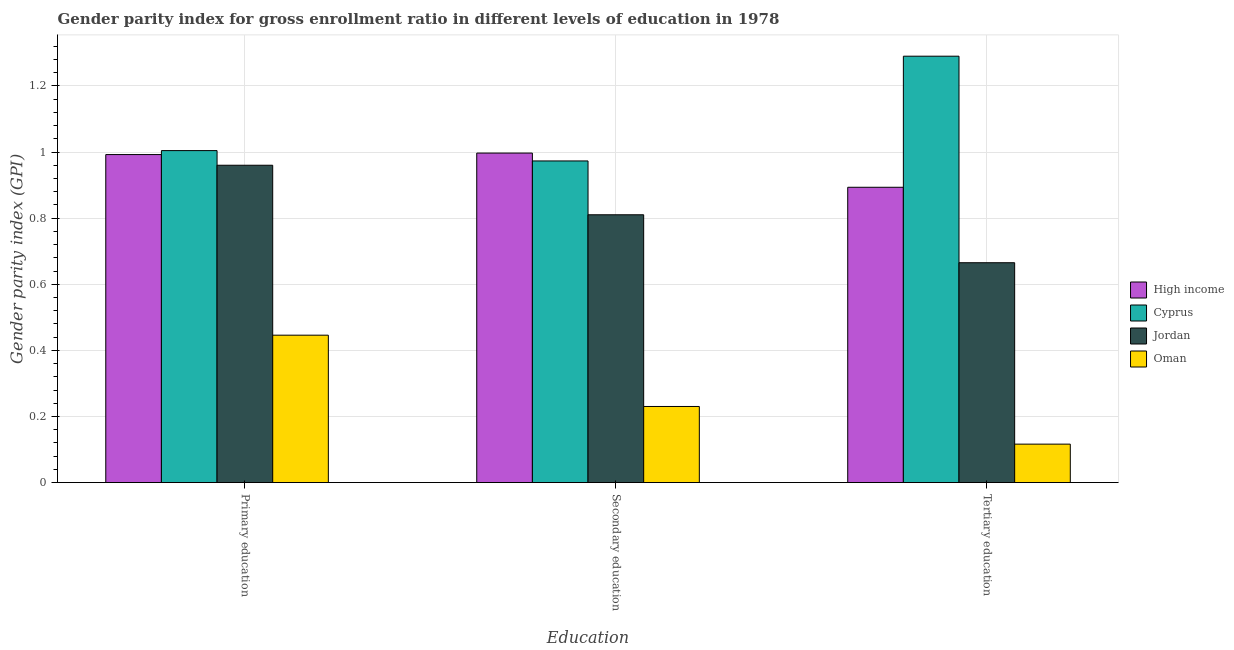How many groups of bars are there?
Provide a short and direct response. 3. How many bars are there on the 2nd tick from the left?
Provide a succinct answer. 4. What is the label of the 2nd group of bars from the left?
Ensure brevity in your answer.  Secondary education. What is the gender parity index in tertiary education in Jordan?
Offer a terse response. 0.67. Across all countries, what is the maximum gender parity index in primary education?
Offer a very short reply. 1. Across all countries, what is the minimum gender parity index in tertiary education?
Give a very brief answer. 0.12. In which country was the gender parity index in tertiary education maximum?
Offer a very short reply. Cyprus. In which country was the gender parity index in tertiary education minimum?
Offer a very short reply. Oman. What is the total gender parity index in tertiary education in the graph?
Make the answer very short. 2.97. What is the difference between the gender parity index in tertiary education in Oman and that in High income?
Provide a succinct answer. -0.78. What is the difference between the gender parity index in tertiary education in Oman and the gender parity index in primary education in Cyprus?
Give a very brief answer. -0.89. What is the average gender parity index in tertiary education per country?
Make the answer very short. 0.74. What is the difference between the gender parity index in secondary education and gender parity index in tertiary education in Jordan?
Offer a terse response. 0.15. In how many countries, is the gender parity index in tertiary education greater than 1 ?
Your answer should be compact. 1. What is the ratio of the gender parity index in tertiary education in Jordan to that in Oman?
Give a very brief answer. 5.71. What is the difference between the highest and the second highest gender parity index in primary education?
Provide a short and direct response. 0.01. What is the difference between the highest and the lowest gender parity index in secondary education?
Provide a short and direct response. 0.77. In how many countries, is the gender parity index in primary education greater than the average gender parity index in primary education taken over all countries?
Your response must be concise. 3. What does the 1st bar from the left in Tertiary education represents?
Your response must be concise. High income. What does the 4th bar from the right in Tertiary education represents?
Make the answer very short. High income. Are all the bars in the graph horizontal?
Keep it short and to the point. No. How many countries are there in the graph?
Provide a succinct answer. 4. Does the graph contain grids?
Ensure brevity in your answer.  Yes. How many legend labels are there?
Keep it short and to the point. 4. How are the legend labels stacked?
Keep it short and to the point. Vertical. What is the title of the graph?
Offer a terse response. Gender parity index for gross enrollment ratio in different levels of education in 1978. Does "Slovak Republic" appear as one of the legend labels in the graph?
Offer a very short reply. No. What is the label or title of the X-axis?
Provide a short and direct response. Education. What is the label or title of the Y-axis?
Your response must be concise. Gender parity index (GPI). What is the Gender parity index (GPI) of High income in Primary education?
Offer a very short reply. 0.99. What is the Gender parity index (GPI) in Cyprus in Primary education?
Make the answer very short. 1. What is the Gender parity index (GPI) of Jordan in Primary education?
Make the answer very short. 0.96. What is the Gender parity index (GPI) of Oman in Primary education?
Your response must be concise. 0.45. What is the Gender parity index (GPI) in High income in Secondary education?
Offer a terse response. 1. What is the Gender parity index (GPI) in Cyprus in Secondary education?
Provide a succinct answer. 0.97. What is the Gender parity index (GPI) of Jordan in Secondary education?
Your answer should be compact. 0.81. What is the Gender parity index (GPI) in Oman in Secondary education?
Make the answer very short. 0.23. What is the Gender parity index (GPI) of High income in Tertiary education?
Provide a short and direct response. 0.89. What is the Gender parity index (GPI) of Cyprus in Tertiary education?
Keep it short and to the point. 1.29. What is the Gender parity index (GPI) in Jordan in Tertiary education?
Offer a very short reply. 0.67. What is the Gender parity index (GPI) in Oman in Tertiary education?
Give a very brief answer. 0.12. Across all Education, what is the maximum Gender parity index (GPI) in High income?
Your answer should be very brief. 1. Across all Education, what is the maximum Gender parity index (GPI) in Cyprus?
Make the answer very short. 1.29. Across all Education, what is the maximum Gender parity index (GPI) of Jordan?
Keep it short and to the point. 0.96. Across all Education, what is the maximum Gender parity index (GPI) of Oman?
Make the answer very short. 0.45. Across all Education, what is the minimum Gender parity index (GPI) of High income?
Your answer should be compact. 0.89. Across all Education, what is the minimum Gender parity index (GPI) in Cyprus?
Your answer should be very brief. 0.97. Across all Education, what is the minimum Gender parity index (GPI) in Jordan?
Offer a very short reply. 0.67. Across all Education, what is the minimum Gender parity index (GPI) of Oman?
Offer a terse response. 0.12. What is the total Gender parity index (GPI) of High income in the graph?
Provide a short and direct response. 2.88. What is the total Gender parity index (GPI) in Cyprus in the graph?
Keep it short and to the point. 3.27. What is the total Gender parity index (GPI) of Jordan in the graph?
Your answer should be very brief. 2.44. What is the total Gender parity index (GPI) in Oman in the graph?
Provide a succinct answer. 0.79. What is the difference between the Gender parity index (GPI) of High income in Primary education and that in Secondary education?
Offer a terse response. -0. What is the difference between the Gender parity index (GPI) of Cyprus in Primary education and that in Secondary education?
Offer a terse response. 0.03. What is the difference between the Gender parity index (GPI) in Jordan in Primary education and that in Secondary education?
Give a very brief answer. 0.15. What is the difference between the Gender parity index (GPI) in Oman in Primary education and that in Secondary education?
Provide a succinct answer. 0.22. What is the difference between the Gender parity index (GPI) in High income in Primary education and that in Tertiary education?
Your response must be concise. 0.1. What is the difference between the Gender parity index (GPI) in Cyprus in Primary education and that in Tertiary education?
Ensure brevity in your answer.  -0.29. What is the difference between the Gender parity index (GPI) of Jordan in Primary education and that in Tertiary education?
Offer a terse response. 0.29. What is the difference between the Gender parity index (GPI) of Oman in Primary education and that in Tertiary education?
Provide a short and direct response. 0.33. What is the difference between the Gender parity index (GPI) of High income in Secondary education and that in Tertiary education?
Keep it short and to the point. 0.1. What is the difference between the Gender parity index (GPI) of Cyprus in Secondary education and that in Tertiary education?
Provide a succinct answer. -0.32. What is the difference between the Gender parity index (GPI) in Jordan in Secondary education and that in Tertiary education?
Your answer should be very brief. 0.15. What is the difference between the Gender parity index (GPI) of Oman in Secondary education and that in Tertiary education?
Keep it short and to the point. 0.11. What is the difference between the Gender parity index (GPI) of High income in Primary education and the Gender parity index (GPI) of Cyprus in Secondary education?
Offer a terse response. 0.02. What is the difference between the Gender parity index (GPI) in High income in Primary education and the Gender parity index (GPI) in Jordan in Secondary education?
Offer a very short reply. 0.18. What is the difference between the Gender parity index (GPI) in High income in Primary education and the Gender parity index (GPI) in Oman in Secondary education?
Ensure brevity in your answer.  0.76. What is the difference between the Gender parity index (GPI) in Cyprus in Primary education and the Gender parity index (GPI) in Jordan in Secondary education?
Provide a short and direct response. 0.19. What is the difference between the Gender parity index (GPI) of Cyprus in Primary education and the Gender parity index (GPI) of Oman in Secondary education?
Your answer should be very brief. 0.77. What is the difference between the Gender parity index (GPI) of Jordan in Primary education and the Gender parity index (GPI) of Oman in Secondary education?
Offer a very short reply. 0.73. What is the difference between the Gender parity index (GPI) of High income in Primary education and the Gender parity index (GPI) of Cyprus in Tertiary education?
Give a very brief answer. -0.3. What is the difference between the Gender parity index (GPI) in High income in Primary education and the Gender parity index (GPI) in Jordan in Tertiary education?
Your answer should be compact. 0.33. What is the difference between the Gender parity index (GPI) in High income in Primary education and the Gender parity index (GPI) in Oman in Tertiary education?
Offer a terse response. 0.88. What is the difference between the Gender parity index (GPI) of Cyprus in Primary education and the Gender parity index (GPI) of Jordan in Tertiary education?
Your answer should be very brief. 0.34. What is the difference between the Gender parity index (GPI) in Cyprus in Primary education and the Gender parity index (GPI) in Oman in Tertiary education?
Your answer should be very brief. 0.89. What is the difference between the Gender parity index (GPI) of Jordan in Primary education and the Gender parity index (GPI) of Oman in Tertiary education?
Make the answer very short. 0.84. What is the difference between the Gender parity index (GPI) in High income in Secondary education and the Gender parity index (GPI) in Cyprus in Tertiary education?
Keep it short and to the point. -0.29. What is the difference between the Gender parity index (GPI) of High income in Secondary education and the Gender parity index (GPI) of Jordan in Tertiary education?
Your response must be concise. 0.33. What is the difference between the Gender parity index (GPI) in High income in Secondary education and the Gender parity index (GPI) in Oman in Tertiary education?
Offer a very short reply. 0.88. What is the difference between the Gender parity index (GPI) of Cyprus in Secondary education and the Gender parity index (GPI) of Jordan in Tertiary education?
Offer a very short reply. 0.31. What is the difference between the Gender parity index (GPI) in Cyprus in Secondary education and the Gender parity index (GPI) in Oman in Tertiary education?
Provide a succinct answer. 0.86. What is the difference between the Gender parity index (GPI) of Jordan in Secondary education and the Gender parity index (GPI) of Oman in Tertiary education?
Provide a short and direct response. 0.69. What is the average Gender parity index (GPI) of High income per Education?
Provide a succinct answer. 0.96. What is the average Gender parity index (GPI) in Cyprus per Education?
Offer a terse response. 1.09. What is the average Gender parity index (GPI) in Jordan per Education?
Offer a very short reply. 0.81. What is the average Gender parity index (GPI) of Oman per Education?
Give a very brief answer. 0.26. What is the difference between the Gender parity index (GPI) in High income and Gender parity index (GPI) in Cyprus in Primary education?
Your response must be concise. -0.01. What is the difference between the Gender parity index (GPI) of High income and Gender parity index (GPI) of Jordan in Primary education?
Your answer should be compact. 0.03. What is the difference between the Gender parity index (GPI) in High income and Gender parity index (GPI) in Oman in Primary education?
Keep it short and to the point. 0.55. What is the difference between the Gender parity index (GPI) of Cyprus and Gender parity index (GPI) of Jordan in Primary education?
Your answer should be very brief. 0.04. What is the difference between the Gender parity index (GPI) in Cyprus and Gender parity index (GPI) in Oman in Primary education?
Your answer should be very brief. 0.56. What is the difference between the Gender parity index (GPI) in Jordan and Gender parity index (GPI) in Oman in Primary education?
Keep it short and to the point. 0.51. What is the difference between the Gender parity index (GPI) of High income and Gender parity index (GPI) of Cyprus in Secondary education?
Offer a terse response. 0.02. What is the difference between the Gender parity index (GPI) in High income and Gender parity index (GPI) in Jordan in Secondary education?
Offer a terse response. 0.19. What is the difference between the Gender parity index (GPI) of High income and Gender parity index (GPI) of Oman in Secondary education?
Your response must be concise. 0.77. What is the difference between the Gender parity index (GPI) in Cyprus and Gender parity index (GPI) in Jordan in Secondary education?
Give a very brief answer. 0.16. What is the difference between the Gender parity index (GPI) in Cyprus and Gender parity index (GPI) in Oman in Secondary education?
Keep it short and to the point. 0.74. What is the difference between the Gender parity index (GPI) in Jordan and Gender parity index (GPI) in Oman in Secondary education?
Provide a succinct answer. 0.58. What is the difference between the Gender parity index (GPI) of High income and Gender parity index (GPI) of Cyprus in Tertiary education?
Your answer should be very brief. -0.4. What is the difference between the Gender parity index (GPI) in High income and Gender parity index (GPI) in Jordan in Tertiary education?
Offer a very short reply. 0.23. What is the difference between the Gender parity index (GPI) in High income and Gender parity index (GPI) in Oman in Tertiary education?
Offer a terse response. 0.78. What is the difference between the Gender parity index (GPI) in Cyprus and Gender parity index (GPI) in Jordan in Tertiary education?
Keep it short and to the point. 0.62. What is the difference between the Gender parity index (GPI) in Cyprus and Gender parity index (GPI) in Oman in Tertiary education?
Offer a very short reply. 1.17. What is the difference between the Gender parity index (GPI) of Jordan and Gender parity index (GPI) of Oman in Tertiary education?
Your answer should be compact. 0.55. What is the ratio of the Gender parity index (GPI) in Cyprus in Primary education to that in Secondary education?
Ensure brevity in your answer.  1.03. What is the ratio of the Gender parity index (GPI) of Jordan in Primary education to that in Secondary education?
Provide a succinct answer. 1.18. What is the ratio of the Gender parity index (GPI) of Oman in Primary education to that in Secondary education?
Your answer should be very brief. 1.94. What is the ratio of the Gender parity index (GPI) of High income in Primary education to that in Tertiary education?
Provide a succinct answer. 1.11. What is the ratio of the Gender parity index (GPI) of Cyprus in Primary education to that in Tertiary education?
Offer a very short reply. 0.78. What is the ratio of the Gender parity index (GPI) in Jordan in Primary education to that in Tertiary education?
Make the answer very short. 1.44. What is the ratio of the Gender parity index (GPI) of Oman in Primary education to that in Tertiary education?
Provide a short and direct response. 3.83. What is the ratio of the Gender parity index (GPI) of High income in Secondary education to that in Tertiary education?
Offer a very short reply. 1.12. What is the ratio of the Gender parity index (GPI) in Cyprus in Secondary education to that in Tertiary education?
Ensure brevity in your answer.  0.75. What is the ratio of the Gender parity index (GPI) of Jordan in Secondary education to that in Tertiary education?
Give a very brief answer. 1.22. What is the ratio of the Gender parity index (GPI) in Oman in Secondary education to that in Tertiary education?
Make the answer very short. 1.98. What is the difference between the highest and the second highest Gender parity index (GPI) of High income?
Keep it short and to the point. 0. What is the difference between the highest and the second highest Gender parity index (GPI) in Cyprus?
Make the answer very short. 0.29. What is the difference between the highest and the second highest Gender parity index (GPI) of Jordan?
Make the answer very short. 0.15. What is the difference between the highest and the second highest Gender parity index (GPI) of Oman?
Your answer should be very brief. 0.22. What is the difference between the highest and the lowest Gender parity index (GPI) in High income?
Offer a very short reply. 0.1. What is the difference between the highest and the lowest Gender parity index (GPI) of Cyprus?
Offer a very short reply. 0.32. What is the difference between the highest and the lowest Gender parity index (GPI) in Jordan?
Make the answer very short. 0.29. What is the difference between the highest and the lowest Gender parity index (GPI) of Oman?
Your answer should be compact. 0.33. 